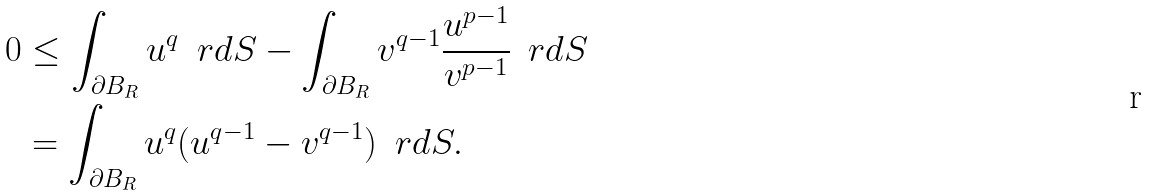Convert formula to latex. <formula><loc_0><loc_0><loc_500><loc_500>0 & \leq \int _ { \partial B _ { R } } u ^ { q } \, \ r d S - \int _ { \partial B _ { R } } v ^ { q - 1 } \frac { u ^ { p - 1 } } { v ^ { p - 1 } } \, \ r d S \\ & = \int _ { \partial B _ { R } } u ^ { q } ( u ^ { q - 1 } - v ^ { q - 1 } ) \, \ r d S .</formula> 